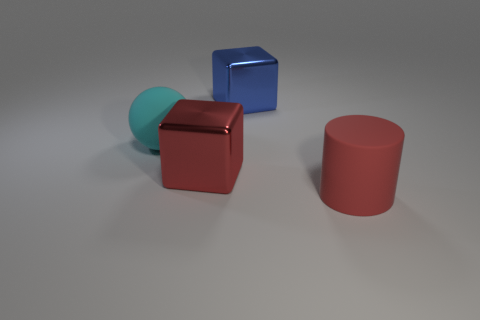What number of blocks are large blue objects or red metal objects?
Your answer should be very brief. 2. Are there any big green matte cylinders?
Keep it short and to the point. No. How many other objects are the same material as the ball?
Give a very brief answer. 1. What is the material of the red object that is the same size as the red cylinder?
Provide a succinct answer. Metal. There is a metallic thing that is on the left side of the blue shiny cube; is its shape the same as the blue object?
Your response must be concise. Yes. Does the cylinder have the same color as the big ball?
Your answer should be very brief. No. What number of things are either matte things to the left of the matte cylinder or large red cubes?
Ensure brevity in your answer.  2. What is the shape of the red rubber object that is the same size as the cyan matte thing?
Ensure brevity in your answer.  Cylinder. Does the red thing that is behind the big matte cylinder have the same size as the matte thing behind the red cylinder?
Ensure brevity in your answer.  Yes. What color is the large cylinder that is made of the same material as the big cyan object?
Your answer should be very brief. Red. 